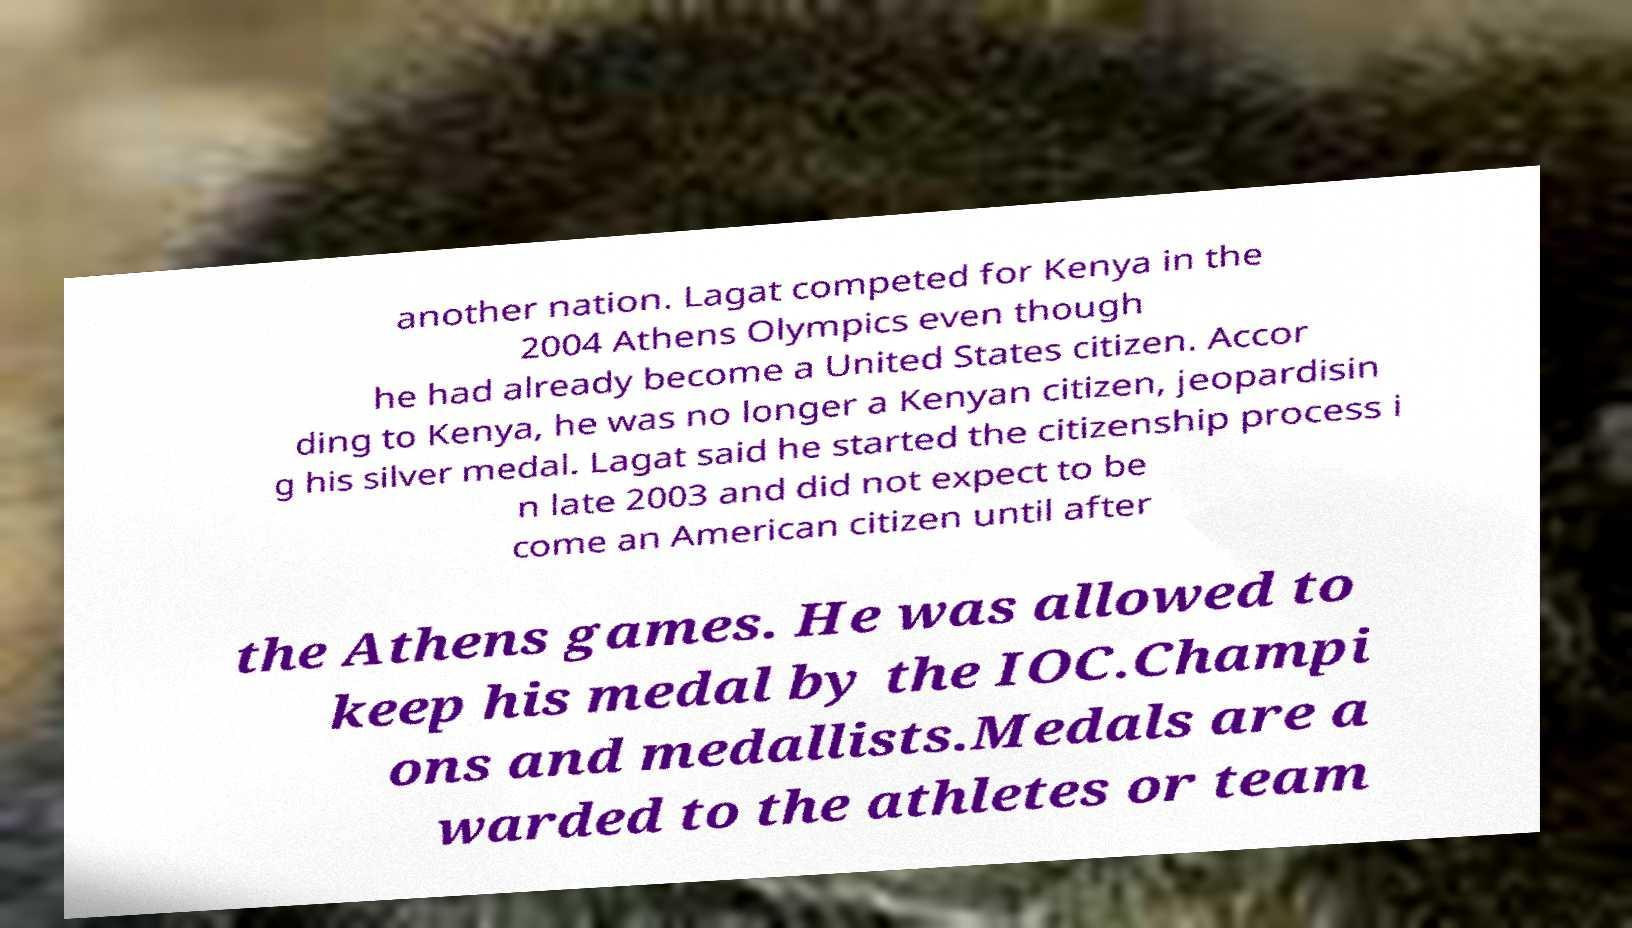Could you assist in decoding the text presented in this image and type it out clearly? another nation. Lagat competed for Kenya in the 2004 Athens Olympics even though he had already become a United States citizen. Accor ding to Kenya, he was no longer a Kenyan citizen, jeopardisin g his silver medal. Lagat said he started the citizenship process i n late 2003 and did not expect to be come an American citizen until after the Athens games. He was allowed to keep his medal by the IOC.Champi ons and medallists.Medals are a warded to the athletes or team 